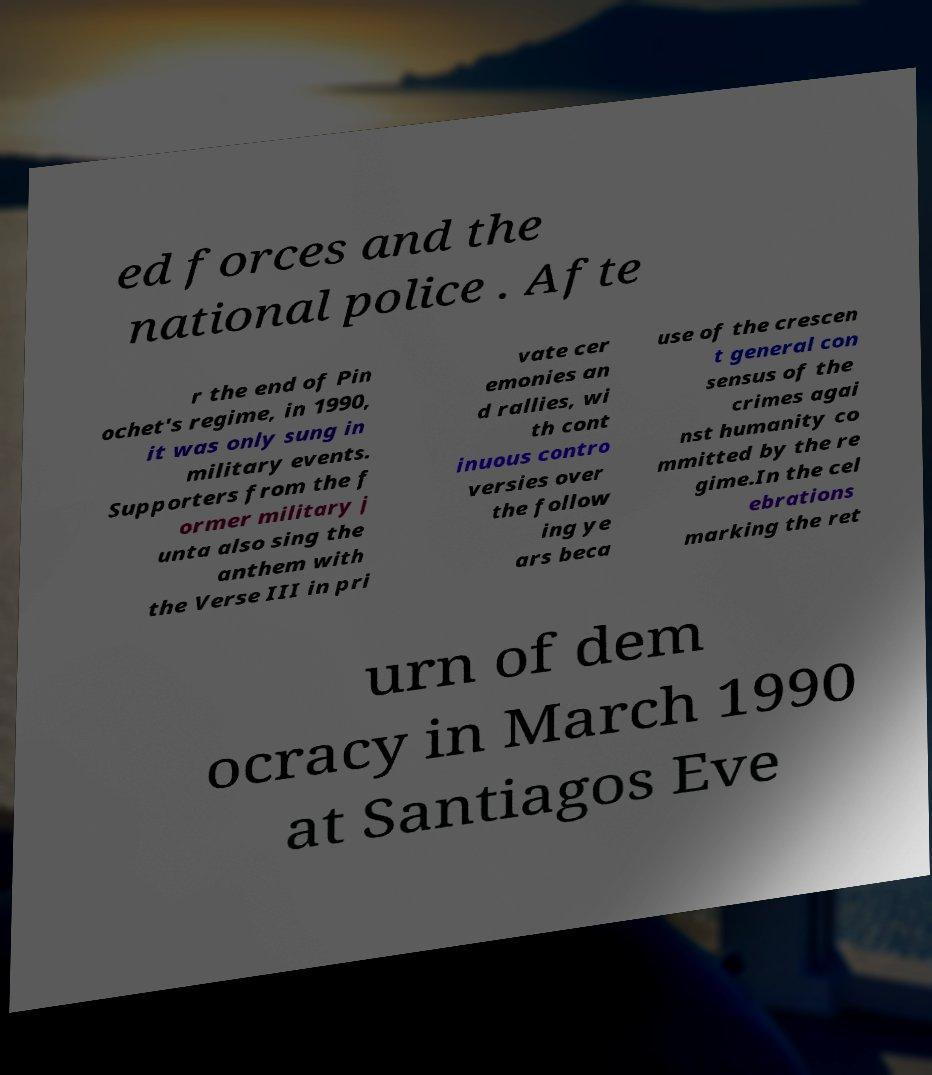For documentation purposes, I need the text within this image transcribed. Could you provide that? ed forces and the national police . Afte r the end of Pin ochet's regime, in 1990, it was only sung in military events. Supporters from the f ormer military j unta also sing the anthem with the Verse III in pri vate cer emonies an d rallies, wi th cont inuous contro versies over the follow ing ye ars beca use of the crescen t general con sensus of the crimes agai nst humanity co mmitted by the re gime.In the cel ebrations marking the ret urn of dem ocracy in March 1990 at Santiagos Eve 